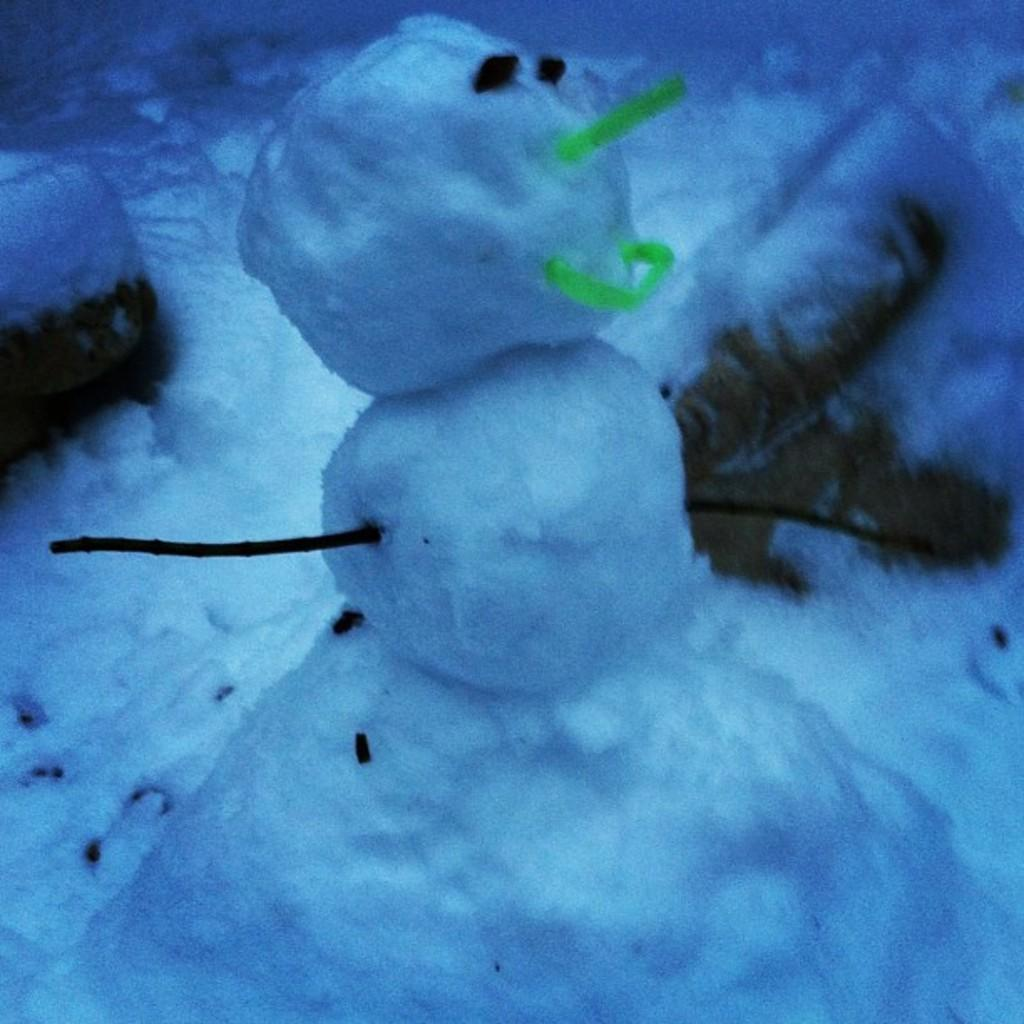What is the predominant color of the image? The image contains white snow. What is the main feature of the image? There is a snowman in the image. What type of linen can be seen draped over the gravestones in the image? There is no cemetery or linen present in the image; it features white snow and a snowman. 